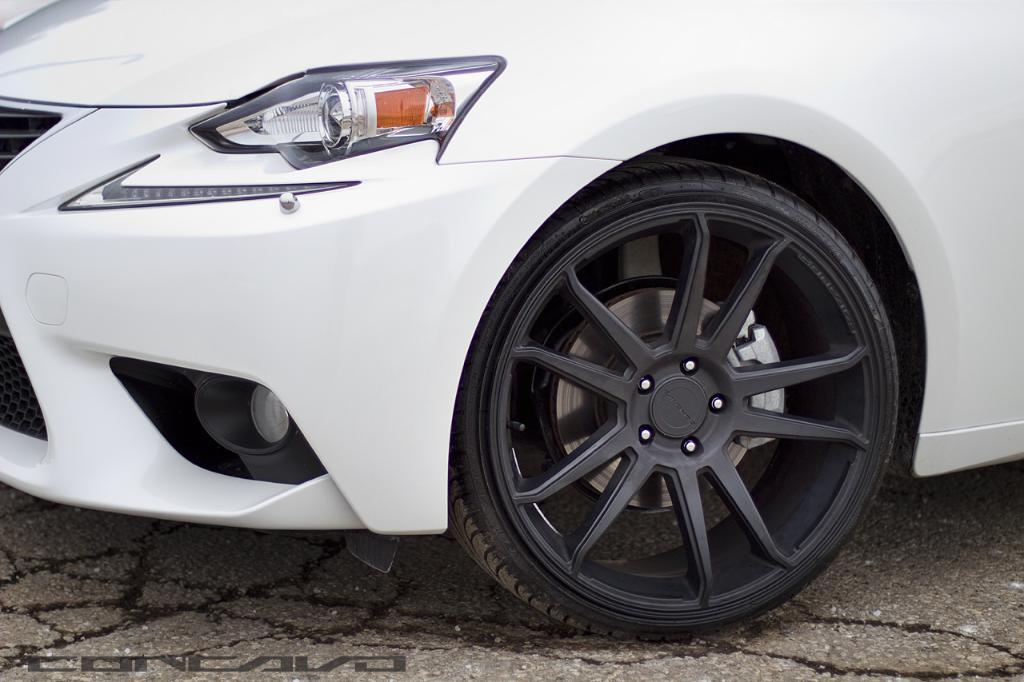What type of vehicle is in the picture? There is a white car in the picture. What part of the car can be seen in the image? The headlight and wheel of the car are visible. What is the setting in which the car is located? The road is visible at the bottom of the picture. What type of toe is visible on the car in the image? There are no toes present in the image, as it features a white car on the road. 